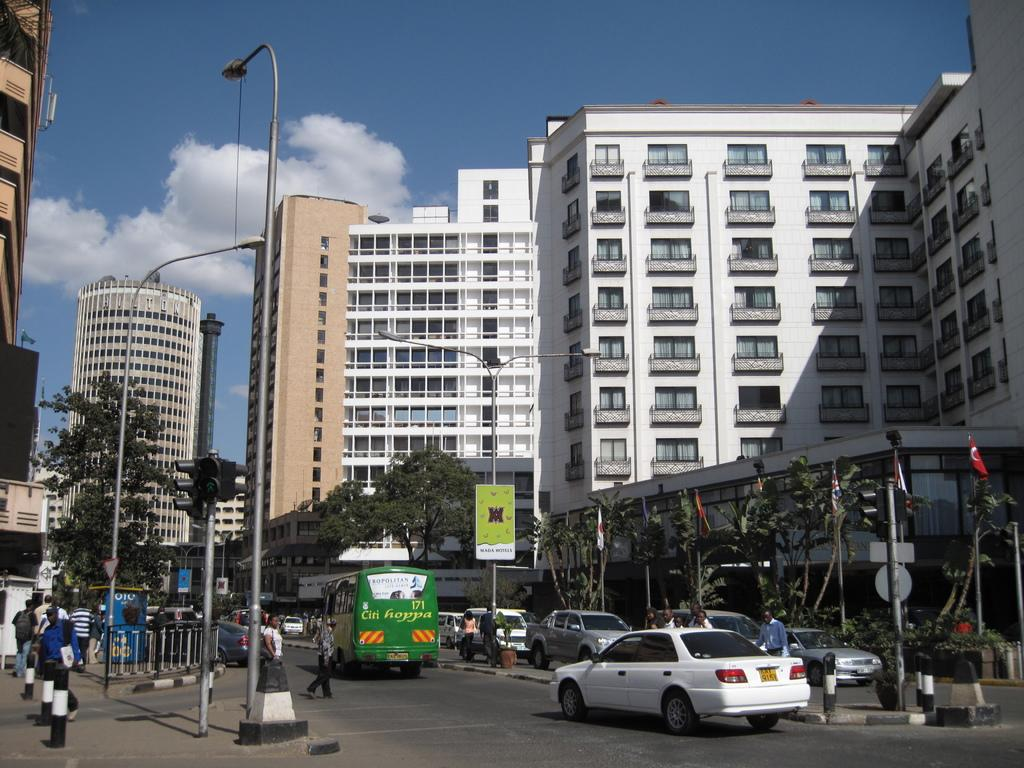What types of objects can be seen in the image? There are vehicles, poles, street lights, trees, people, railing, flags, and buildings visible in the image. What structures are present in the image? There are poles, street lights, railing, flags, and buildings present in the image. What can be seen in the sky in the image? The sky is visible in the image, and there are clouds present. How many elements can be seen in the sky? There is one element visible in the sky, which are the clouds. What type of army is marching through the image? There is no army present in the image; it features vehicles, poles, street lights, trees, people, railing, flags, and buildings. Who is the creator of the vehicles in the image? The factual information provided does not mention the creator of the vehicles, so it cannot be determined from the image. 